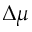<formula> <loc_0><loc_0><loc_500><loc_500>\Delta \mu</formula> 